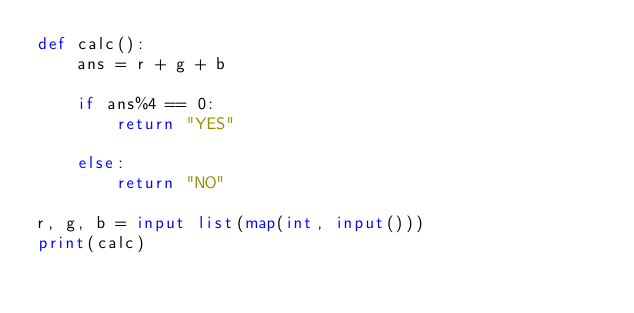Convert code to text. <code><loc_0><loc_0><loc_500><loc_500><_Python_>def calc():
    ans = r + g + b
    
    if ans%4 == 0:
        return "YES"
    
    else:
        return "NO"

r, g, b = input list(map(int, input()))
print(calc)</code> 